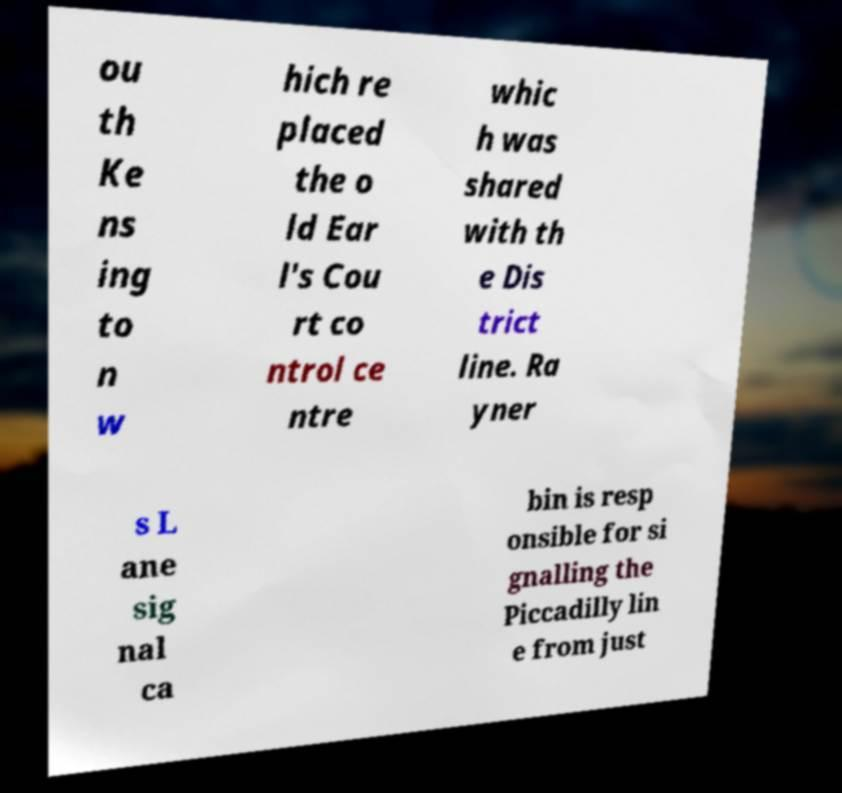For documentation purposes, I need the text within this image transcribed. Could you provide that? ou th Ke ns ing to n w hich re placed the o ld Ear l's Cou rt co ntrol ce ntre whic h was shared with th e Dis trict line. Ra yner s L ane sig nal ca bin is resp onsible for si gnalling the Piccadilly lin e from just 